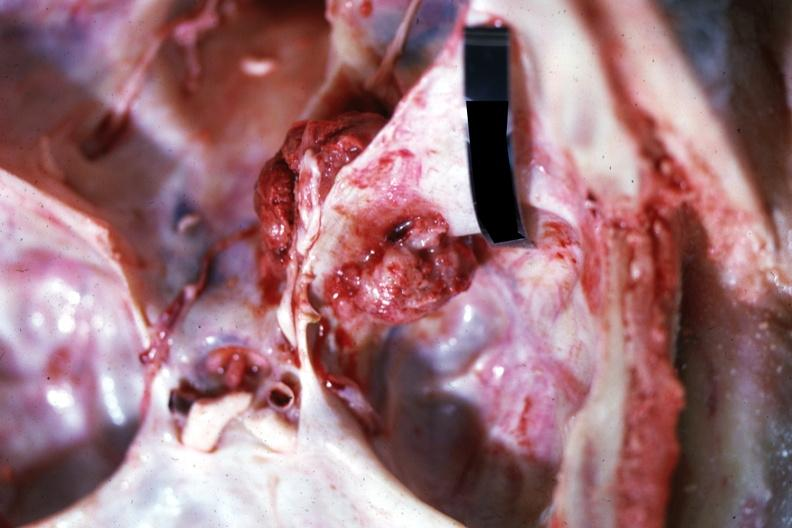s atrophy present?
Answer the question using a single word or phrase. No 